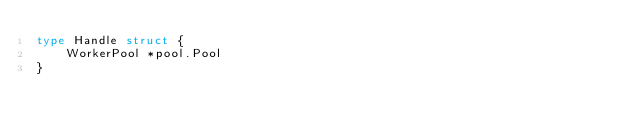<code> <loc_0><loc_0><loc_500><loc_500><_Go_>type Handle struct {
	WorkerPool *pool.Pool
}
</code> 